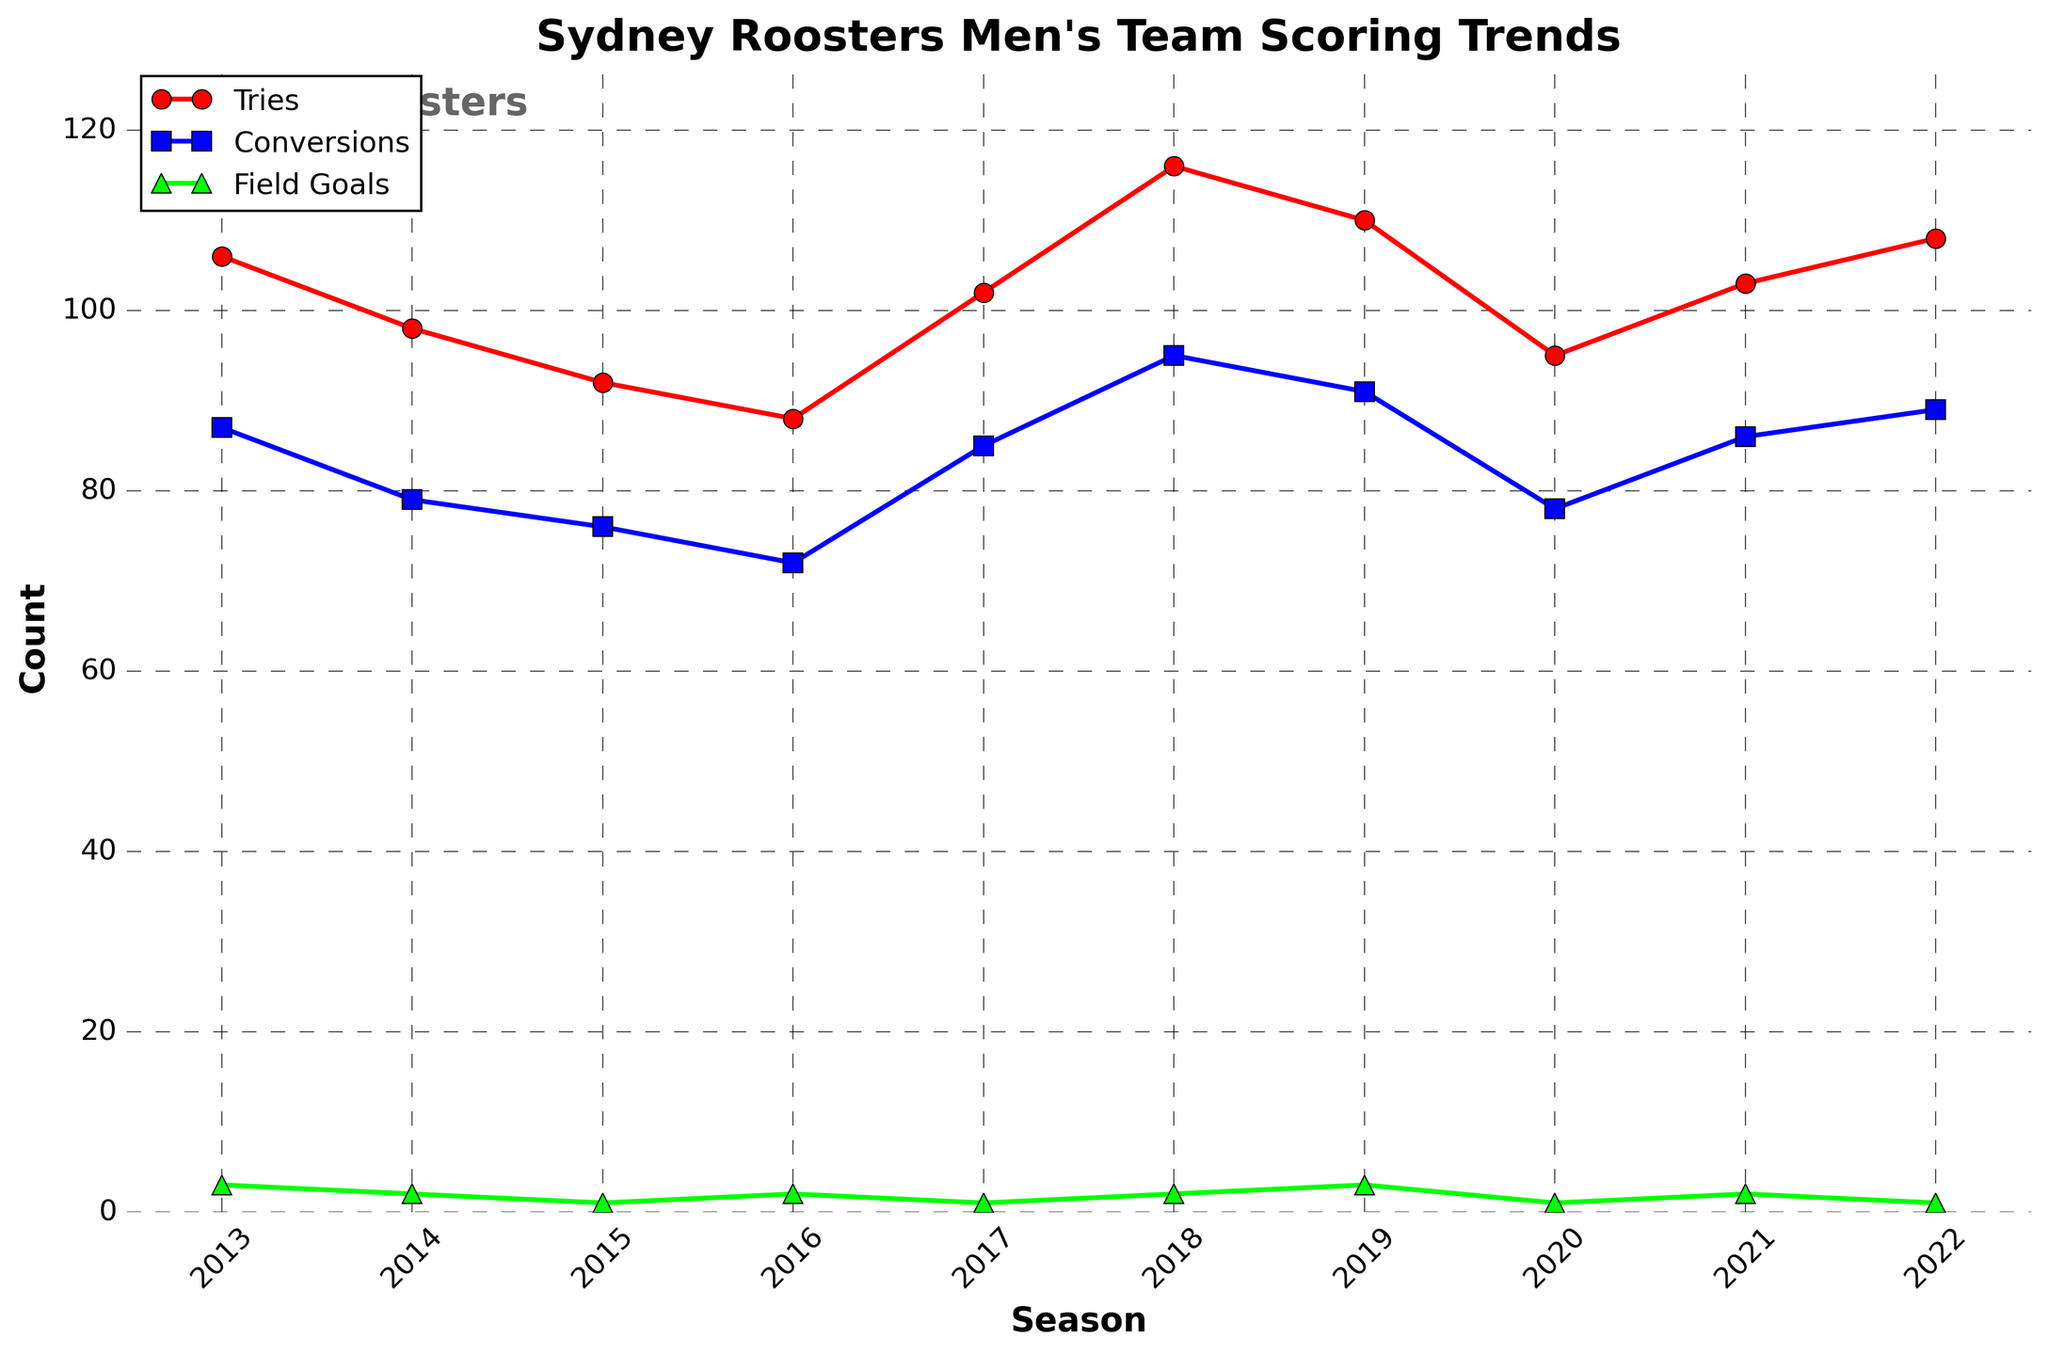What was the season with the highest number of tries? Look at the line representing tries and find the data point with the highest value. The highest point on the red line is in the 2018 season.
Answer: 2018 Which season had more conversions: 2014 or 2017? Compare the heights of the blue line markers corresponding to the 2014 and 2017 seasons. The marker for 2017 is higher than the one for 2014.
Answer: 2017 How many more tries were scored in 2018 compared to 2015? Find the values for tries in the 2018 and 2015 seasons from the red line (2018: 116, 2015: 92), then subtract 92 from 116.
Answer: 24 Which season had the lowest number of field goals? Identify the lowest point on the green line. The lowest points are in the 2015, 2017, 2020, and 2022 seasons, all with a value of 1.
Answer: 2015, 2017, 2020, 2022 Is there a season where the number of tries and conversions are equal? Compare the red and blue lines for each season to check if any data points overlap perfectly. No data points for tries and conversions overlap.
Answer: No What is the average number of tries scored per season over the 10 seasons? Sum the tries for all seasons (106 + 98 + 92 + 88 + 102 + 116 + 110 + 95 + 103 + 108 = 1018) and divide by the number of seasons (10).
Answer: 101.8 Which season had the smallest difference between the number of tries and conversions? Calculate the absolute difference between tries and conversions for each season, then find the smallest difference (2016 with 88 - 72 = 16, 2014 with 98 - 79 = 19, and so on). The smallest difference is in the 2019 season, with a difference of 19.
Answer: 2019 How did the number of tries scored in 2022 compare to the previous season? Look at the values of the red line for the 2021 and 2022 seasons and compare them. The 2021 season had 103 tries, and the 2022 season had 108 tries, so there was an increase.
Answer: Increased Which has the greater range of counts over the 10 seasons: tries, conversions, or field goals? Calculate the range for each category: Tries (116 - 88 = 28), Conversions (95 - 72 = 23), Field Goals (3 - 1 = 2). The greatest range is for tries.
Answer: Tries 